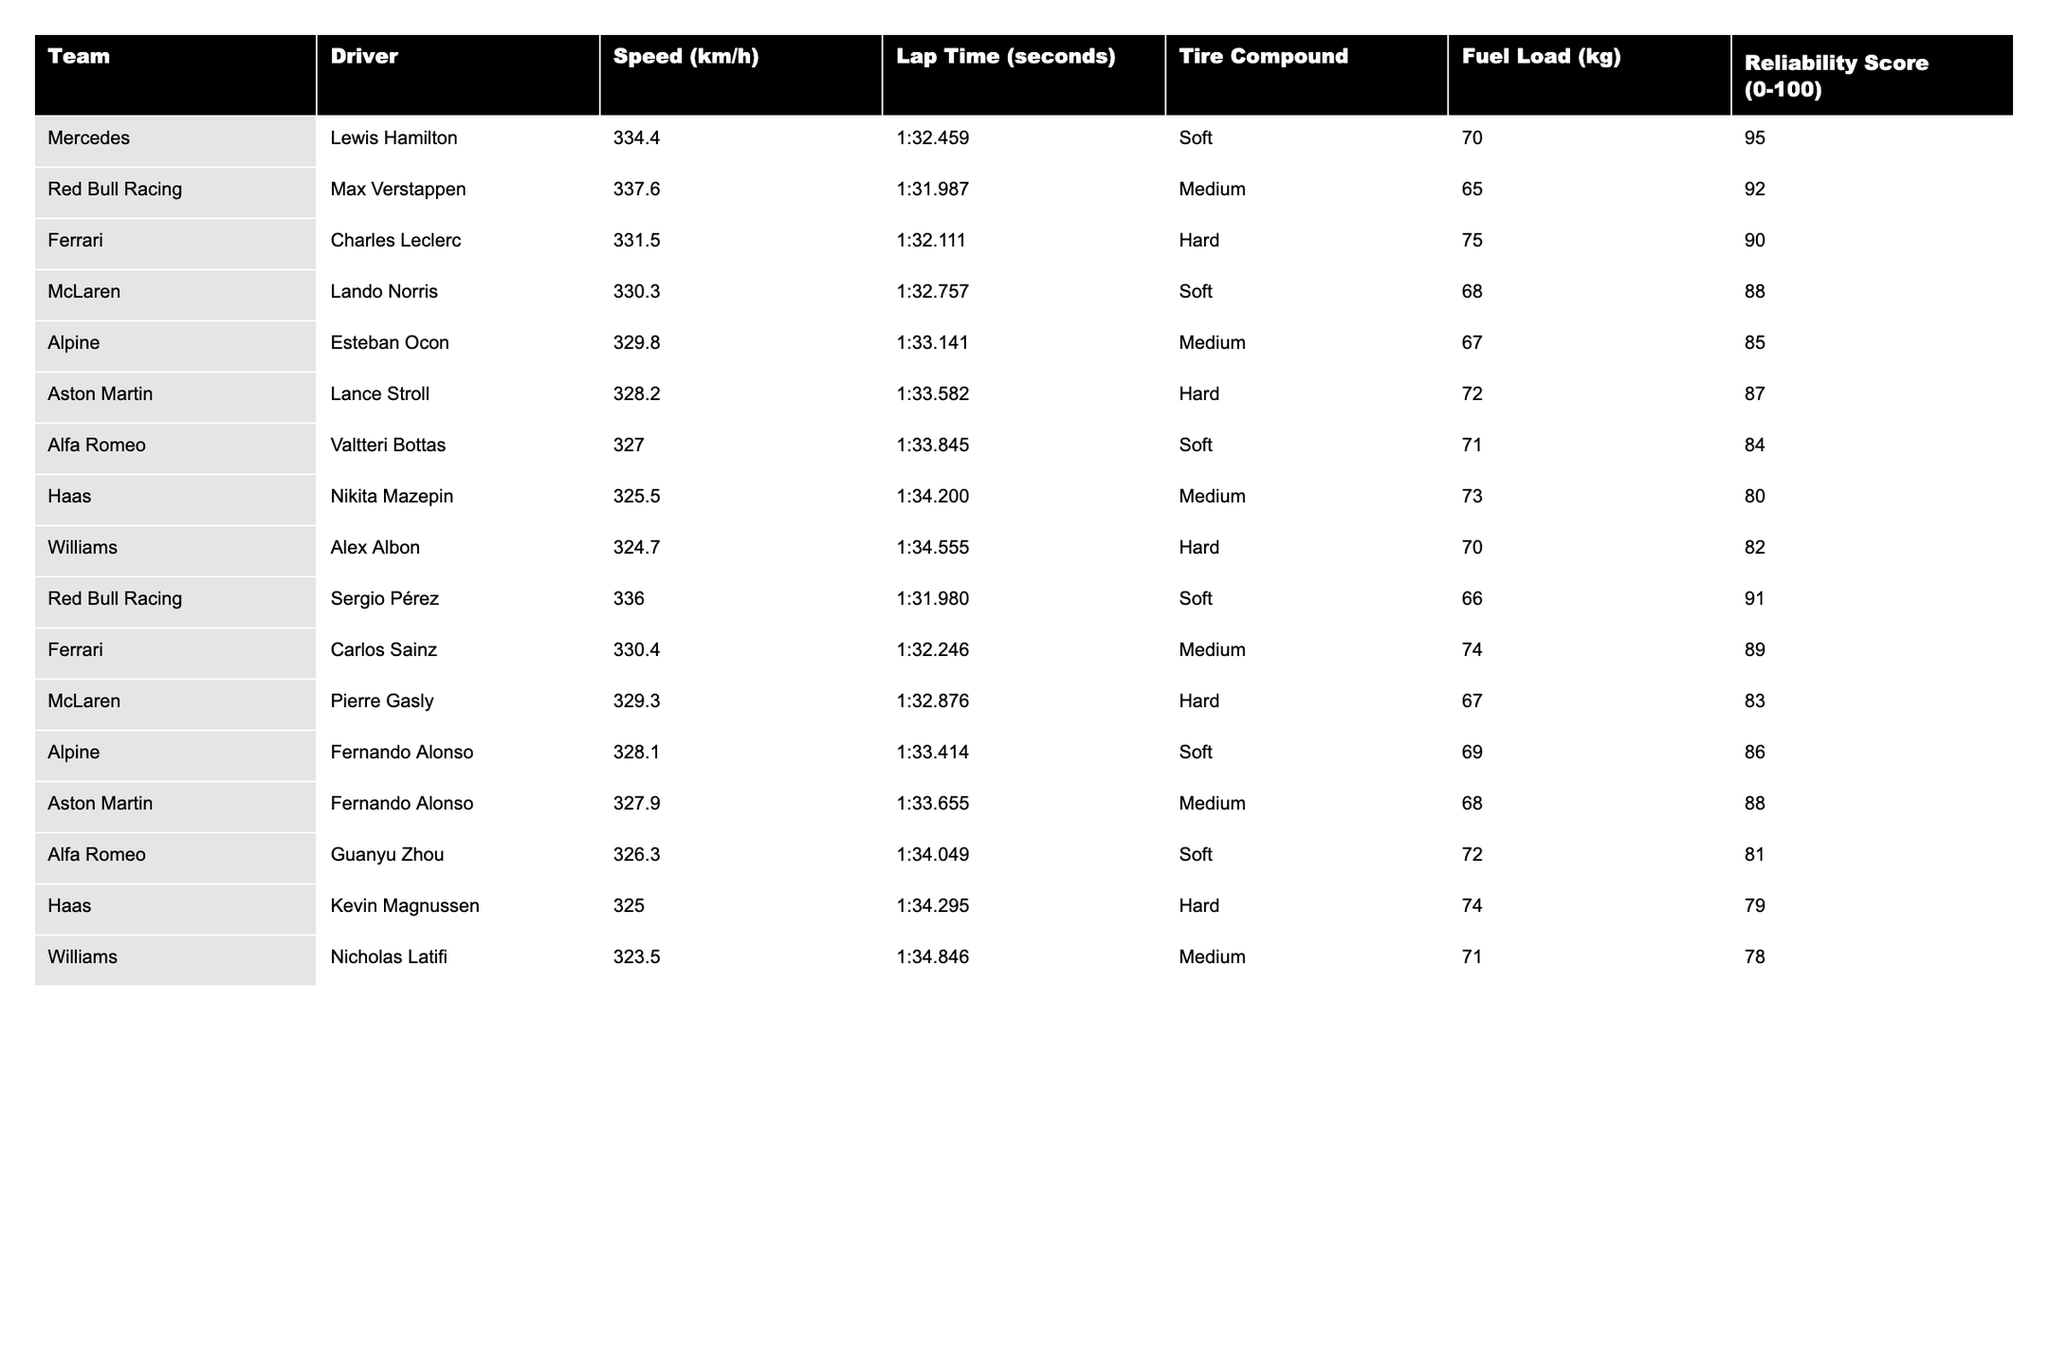What is the fastest car in the 2023 season according to the table? By looking at the 'Speed (km/h)' column, Red Bull Racing's Max Verstappen has the highest speed recorded at 337.6 km/h.
Answer: 337.6 km/h Which driver has the lowest reliability score? Examining the 'Reliability Score' column, Kevin Magnussen from Haas has the lowest score at 79.
Answer: 79 What is the average lap time of Ferrari drivers? For the Ferrari team, the lap times are 1:32.111 for Charles Leclerc and 1:32.246 for Carlos Sainz. First, convert the lap times to seconds (i.e., 32.111 seconds and 32.246 seconds), calculate the average (32.111 + 32.246) / 2 = 32.1785 seconds, and convert it back to the mm:ss format. This results in an average lap time of approximately 1:32.179.
Answer: 1:32.179 Is it true that both McLaren drivers used the Soft tire compound? The table shows that Lando Norris used the Soft compound, while Pierre Gasly used the Hard compound. Therefore, not both McLaren drivers used the Soft tire.
Answer: False What is the difference in average speed between Mercedes and Williams? The speeds for Mercedes are 334.4 km/h (Hamilton) and for Williams are 324.7 km/h (Albon). The average speed for Mercedes is 334.4 km/h. The average speed for Williams is 324.7 km/h. The difference is 334.4 - 324.7 = 9.7 km/h.
Answer: 9.7 km/h Which team has the highest reliability score, and what is it? Reviewing the 'Reliability Score' column, Mercedes has the highest reliability score at 95. The information is clear in the table as it shows that no other team has a reliability score higher than this.
Answer: 95 What is the overall average fuel load of the drivers in the table? The fuel loads are 70, 65, 75, 68, 67, 72, 71, 73, 70, 66, 74, 67, 69, 68, 72, 74, 71, totaling 1300 kg. There are 18 drivers; dividing 1300 by 18 results in an average fuel load of approximately 72.22 kg, rounded to two decimal points.
Answer: 72.22 kg Which tire compound is used most frequently by the drivers listed in the table? We can tally the tire compounds from the table: Soft (6), Medium (6), Hard (6). Therefore, there is no single compound used more frequently than the others. All three compounds are used equally at 6 times each.
Answer: None, all are used equally What is the lap time difference between the fastest and slowest driver? The fastest lap time in the table is 1:31.980 by Sergio Pérez. The slowest lap time is 1:34.846 by Nicholas Latifi. First, convert both to seconds: 91.980 and 94.846 seconds. Next, calculate the difference: 94.846 - 91.980 = 2.866 seconds.
Answer: 2.866 seconds 